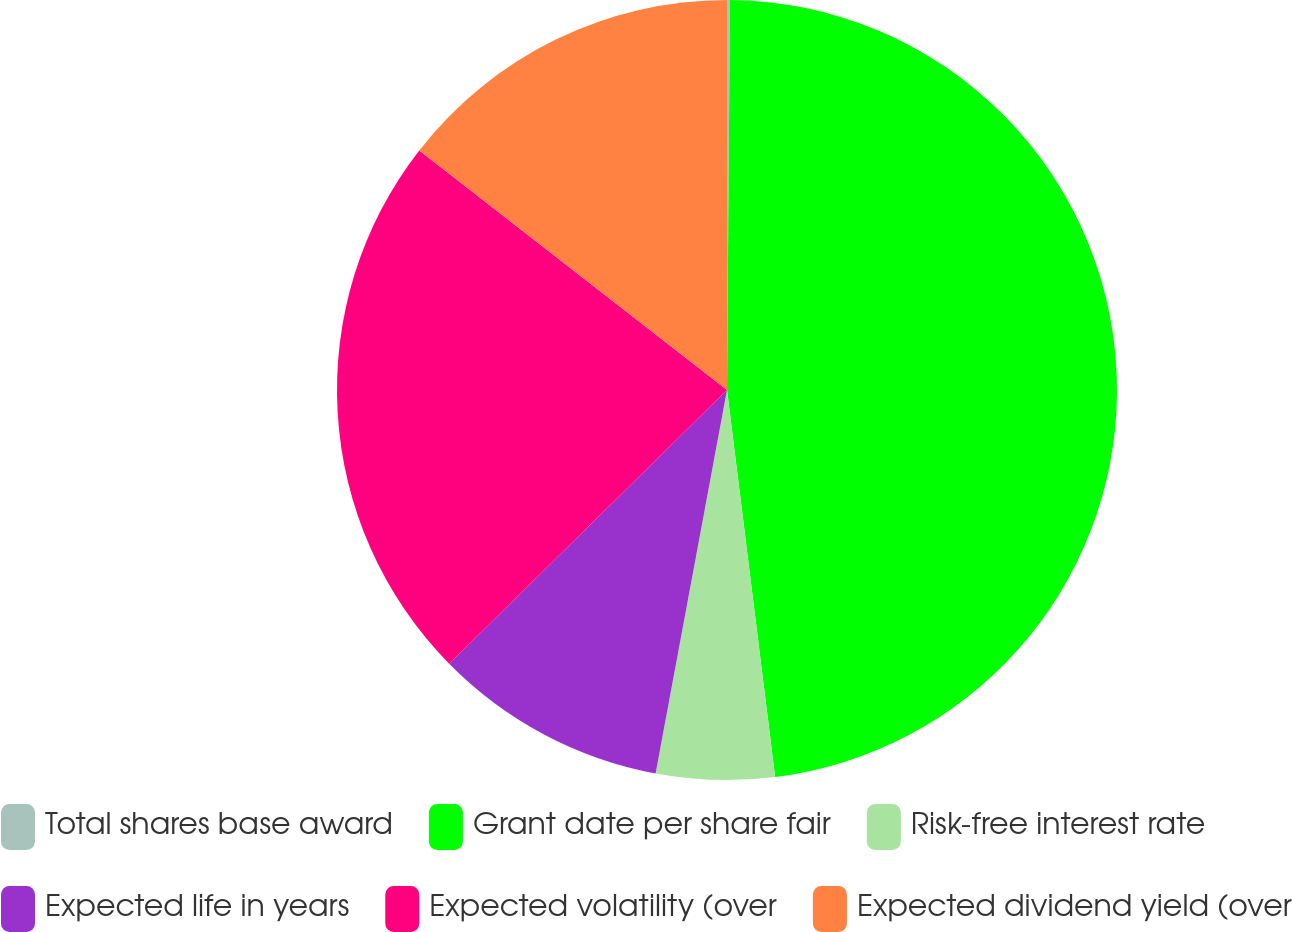Convert chart. <chart><loc_0><loc_0><loc_500><loc_500><pie_chart><fcel>Total shares base award<fcel>Grant date per share fair<fcel>Risk-free interest rate<fcel>Expected life in years<fcel>Expected volatility (over<fcel>Expected dividend yield (over<nl><fcel>0.12%<fcel>47.91%<fcel>4.9%<fcel>9.69%<fcel>22.91%<fcel>14.47%<nl></chart> 